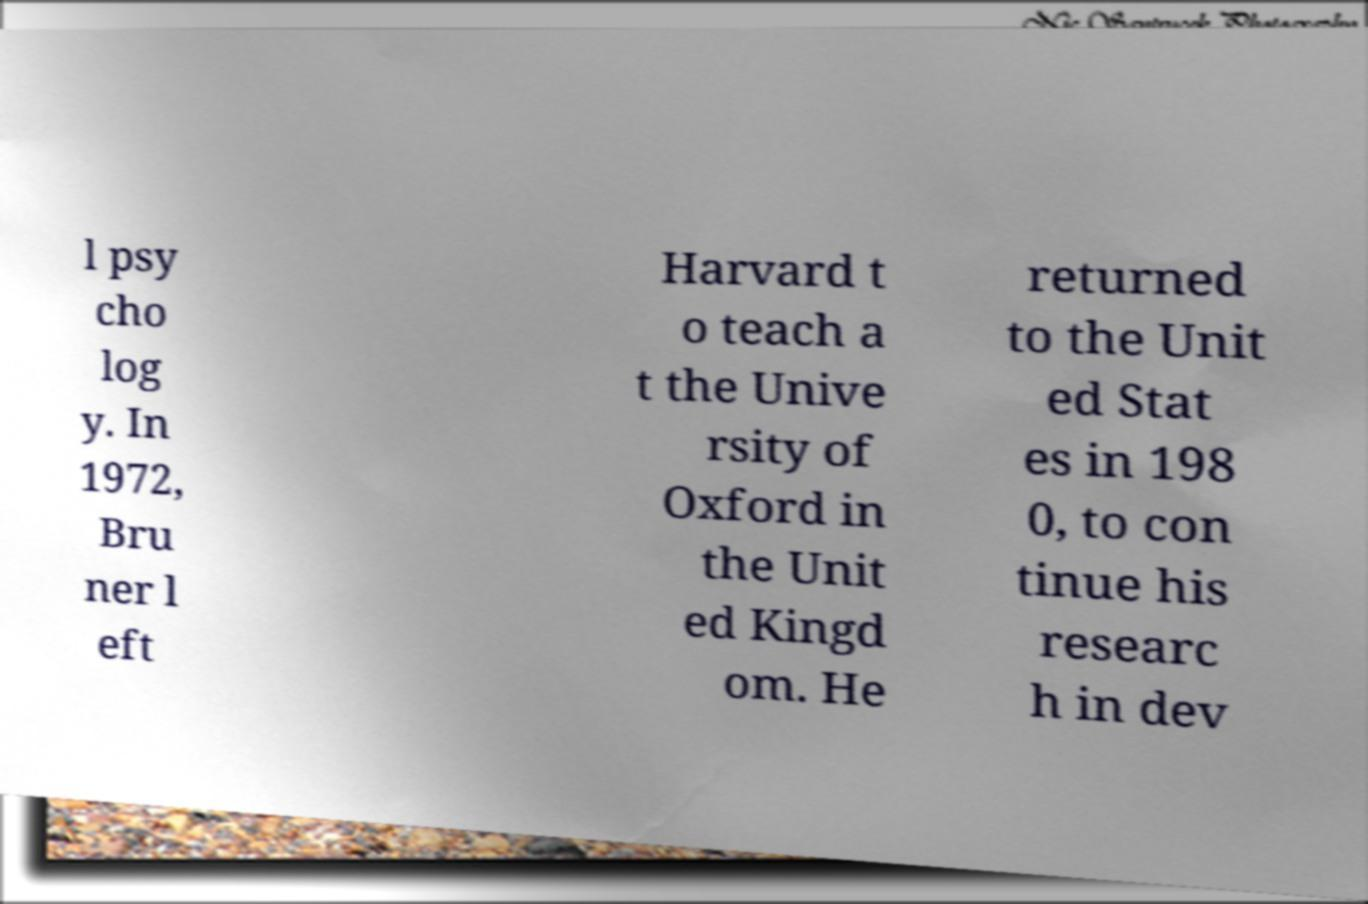Please identify and transcribe the text found in this image. l psy cho log y. In 1972, Bru ner l eft Harvard t o teach a t the Unive rsity of Oxford in the Unit ed Kingd om. He returned to the Unit ed Stat es in 198 0, to con tinue his researc h in dev 